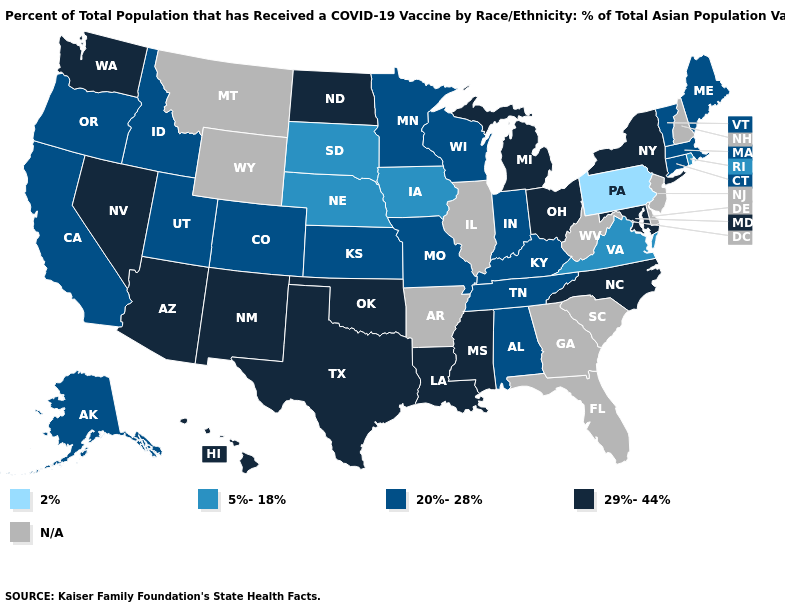Name the states that have a value in the range N/A?
Answer briefly. Arkansas, Delaware, Florida, Georgia, Illinois, Montana, New Hampshire, New Jersey, South Carolina, West Virginia, Wyoming. Name the states that have a value in the range 5%-18%?
Keep it brief. Iowa, Nebraska, Rhode Island, South Dakota, Virginia. Does Pennsylvania have the lowest value in the USA?
Quick response, please. Yes. What is the value of Missouri?
Concise answer only. 20%-28%. What is the lowest value in the USA?
Concise answer only. 2%. What is the value of Louisiana?
Write a very short answer. 29%-44%. Among the states that border South Carolina , which have the highest value?
Short answer required. North Carolina. What is the highest value in states that border Utah?
Concise answer only. 29%-44%. Does New York have the highest value in the Northeast?
Keep it brief. Yes. Does California have the lowest value in the West?
Write a very short answer. Yes. Which states have the lowest value in the Northeast?
Short answer required. Pennsylvania. What is the highest value in the USA?
Answer briefly. 29%-44%. Does the map have missing data?
Write a very short answer. Yes. Name the states that have a value in the range 2%?
Concise answer only. Pennsylvania. Name the states that have a value in the range 20%-28%?
Keep it brief. Alabama, Alaska, California, Colorado, Connecticut, Idaho, Indiana, Kansas, Kentucky, Maine, Massachusetts, Minnesota, Missouri, Oregon, Tennessee, Utah, Vermont, Wisconsin. 